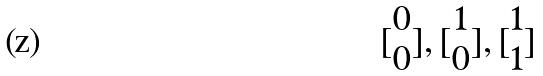<formula> <loc_0><loc_0><loc_500><loc_500>[ \begin{matrix} 0 \\ 0 \end{matrix} ] , [ \begin{matrix} 1 \\ 0 \end{matrix} ] , [ \begin{matrix} 1 \\ 1 \end{matrix} ]</formula> 